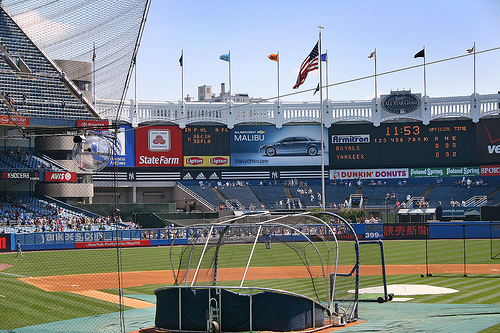<image>
Is the flag under the car? No. The flag is not positioned under the car. The vertical relationship between these objects is different. Is there a flag above the batting cage? Yes. The flag is positioned above the batting cage in the vertical space, higher up in the scene. 